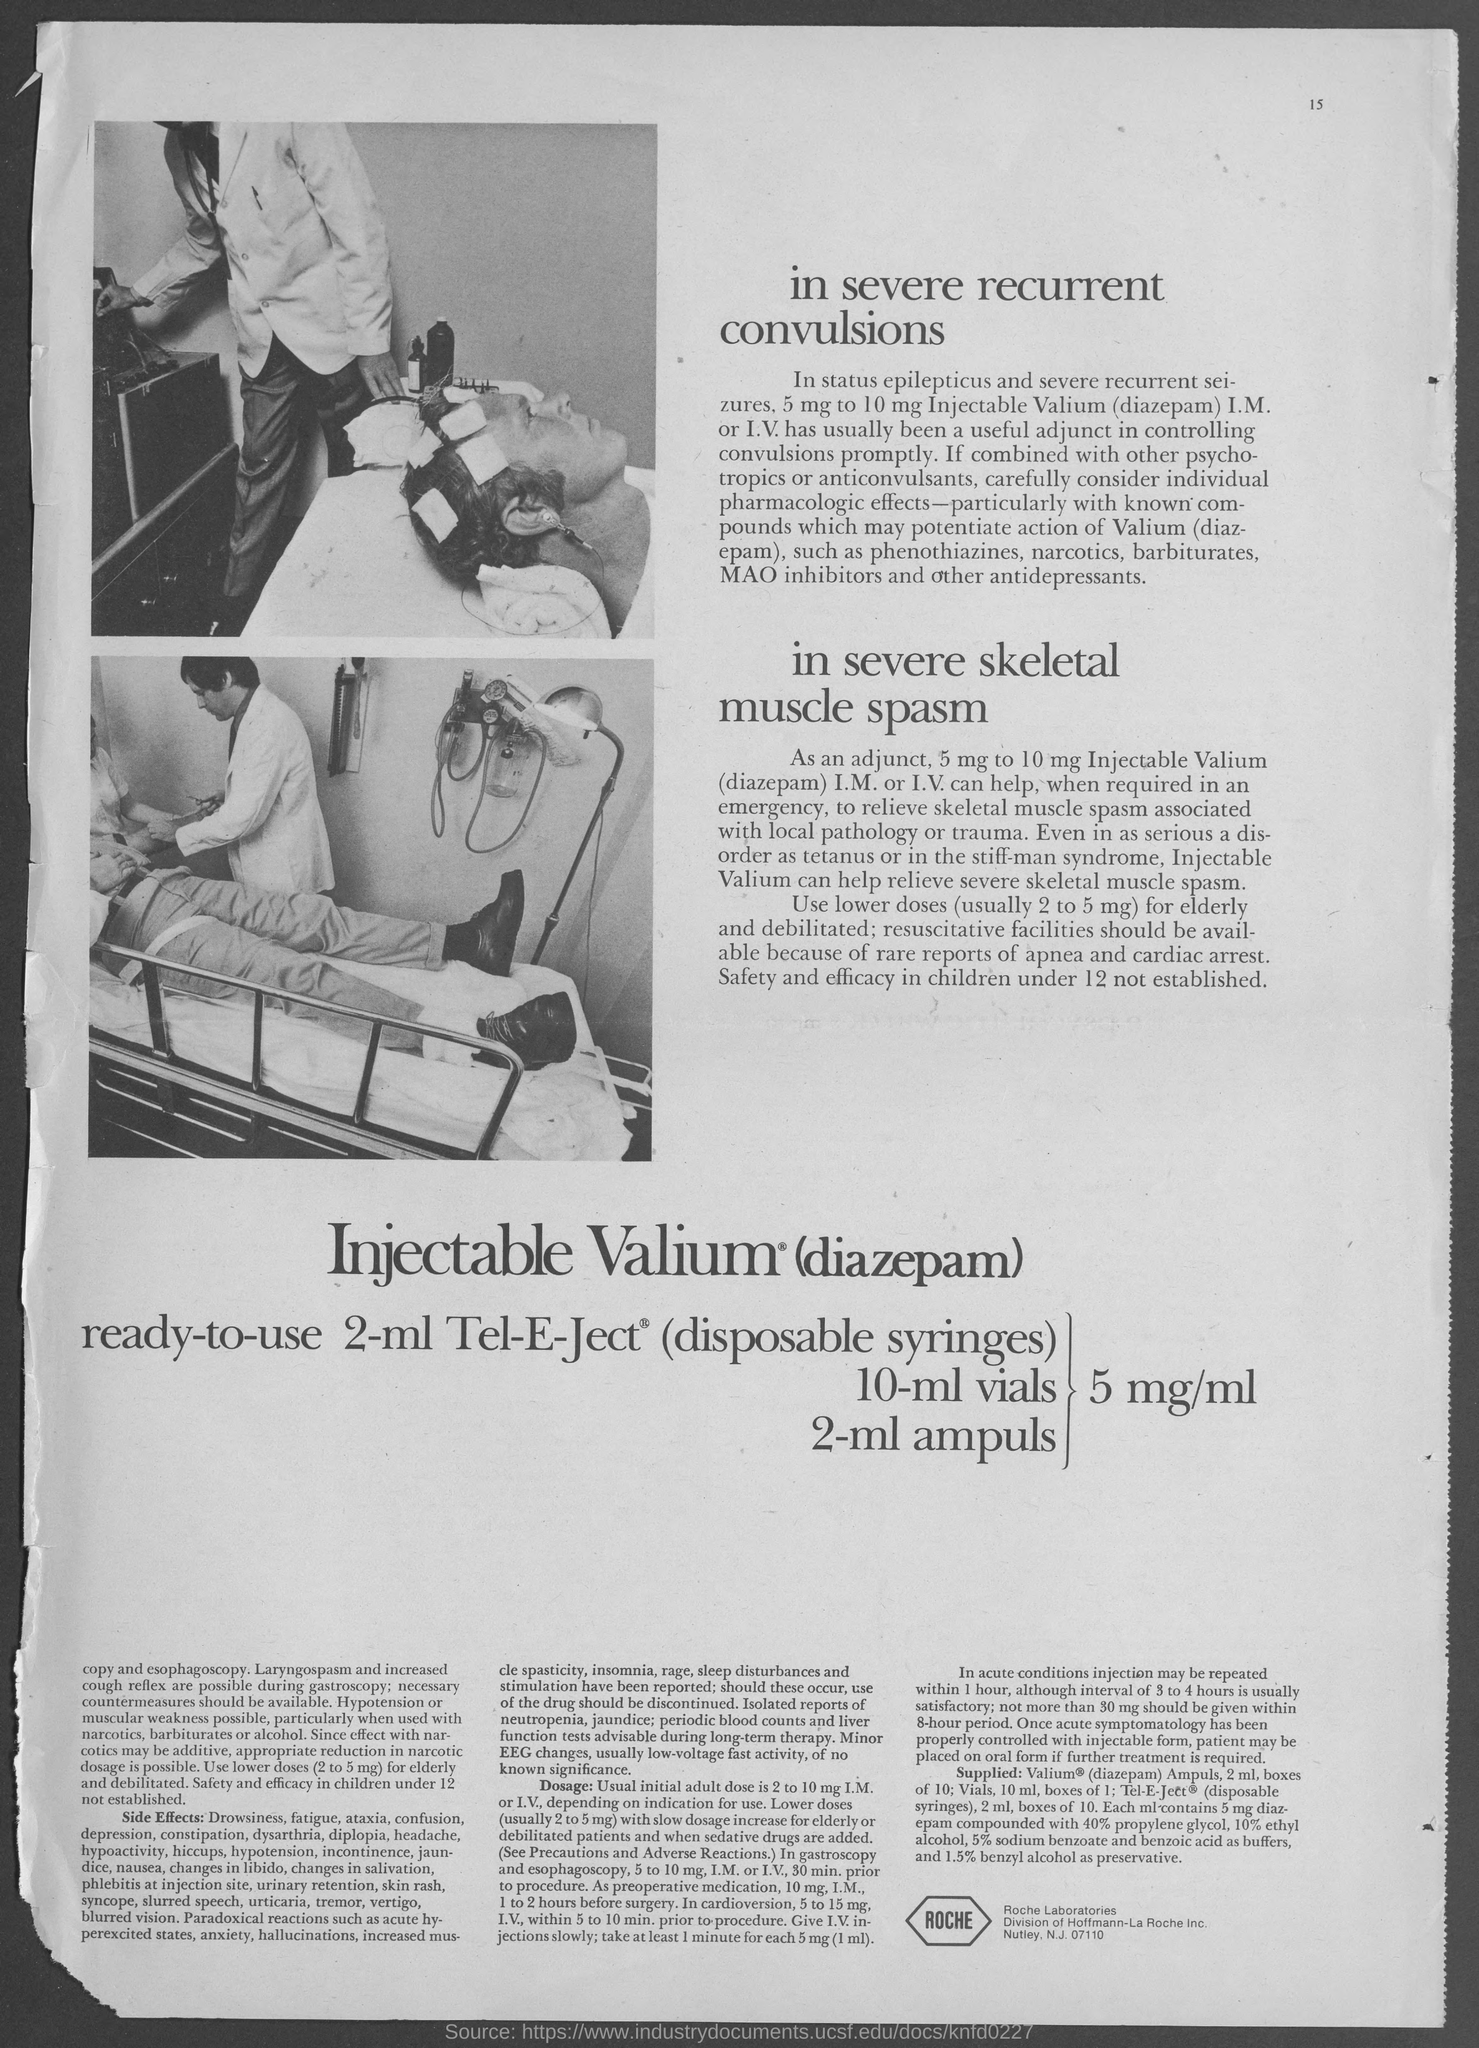In which city is roche laboratories at ?
Offer a very short reply. Nutley. 